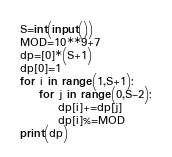<code> <loc_0><loc_0><loc_500><loc_500><_Python_>S=int(input())
MOD=10**9+7
dp=[0]*(S+1)
dp[0]=1
for i in range(1,S+1):
    for j in range(0,S-2):
        dp[i]+=dp[j]
        dp[i]%=MOD
print(dp)</code> 